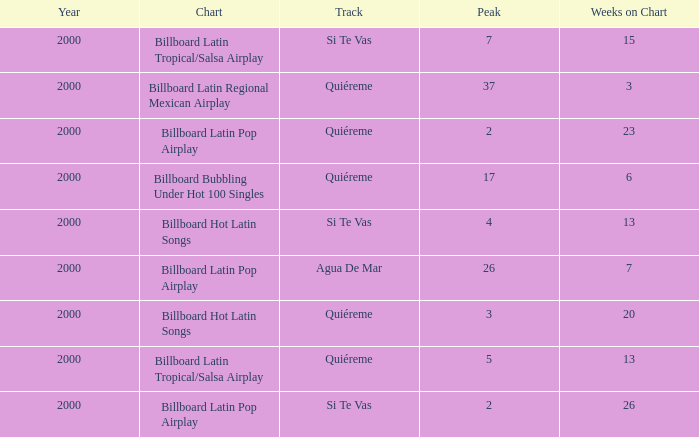Name the least weeks for year less than 2000 None. 